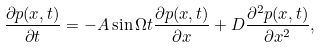Convert formula to latex. <formula><loc_0><loc_0><loc_500><loc_500>\frac { \partial p ( x , t ) } { \partial t } = - A \sin \Omega t \frac { \partial p ( x , t ) } { \partial x } + D \frac { \partial ^ { 2 } p ( x , t ) } { \partial x ^ { 2 } } ,</formula> 